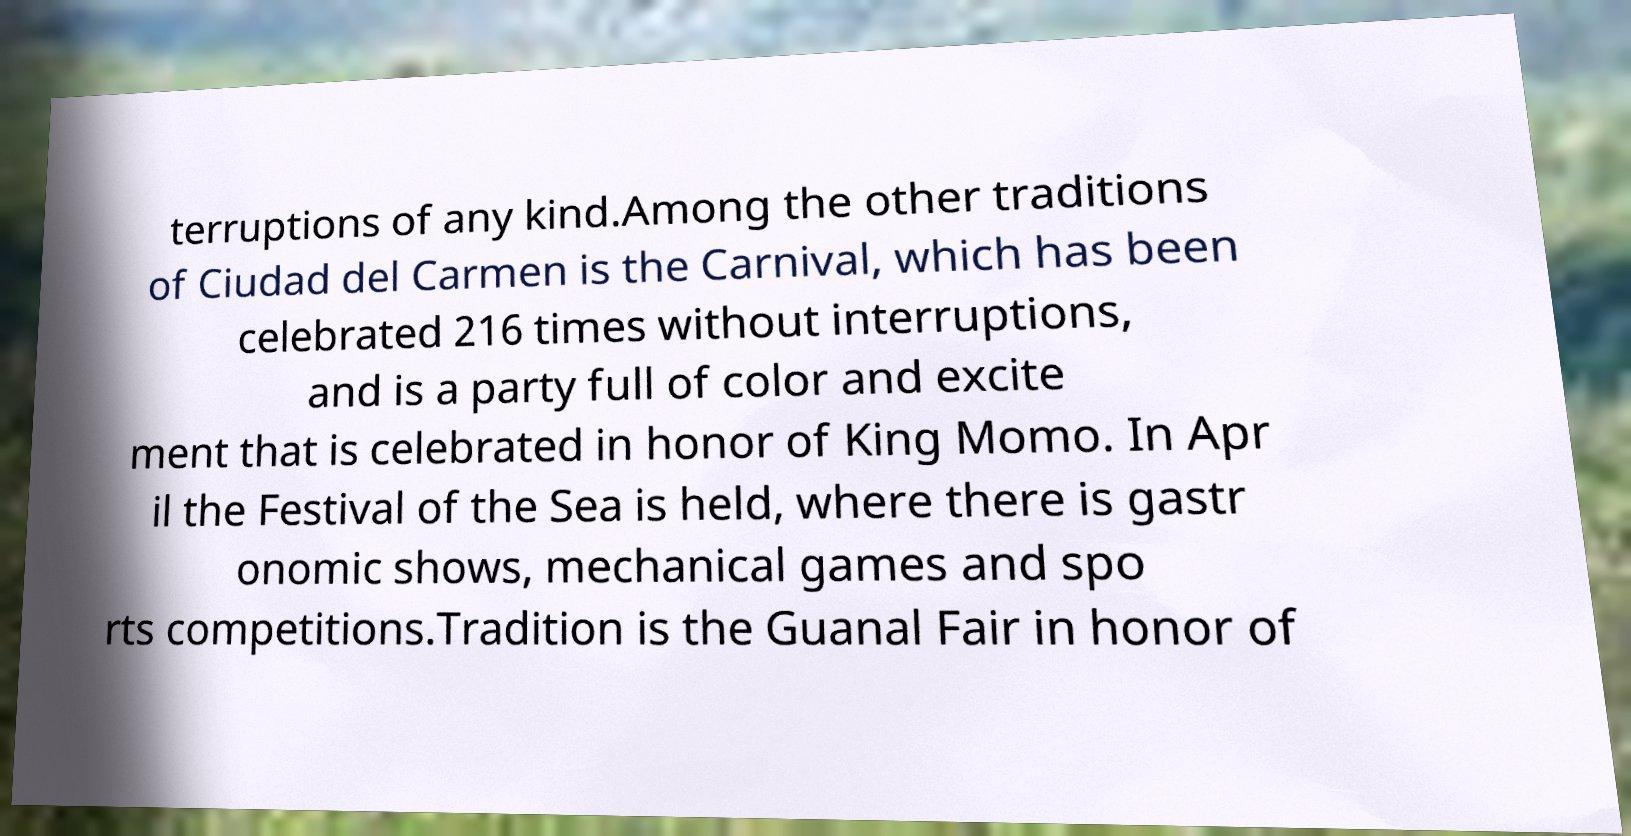Please identify and transcribe the text found in this image. terruptions of any kind.Among the other traditions of Ciudad del Carmen is the Carnival, which has been celebrated 216 times without interruptions, and is a party full of color and excite ment that is celebrated in honor of King Momo. In Apr il the Festival of the Sea is held, where there is gastr onomic shows, mechanical games and spo rts competitions.Tradition is the Guanal Fair in honor of 